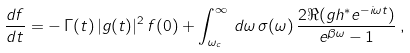Convert formula to latex. <formula><loc_0><loc_0><loc_500><loc_500>\frac { d f } { d t } = - \, \Gamma ( t ) \, | g ( t ) | ^ { 2 } \, f ( 0 ) + \int _ { \omega _ { c } } ^ { \infty } \, d \omega \, \sigma ( \omega ) \, \frac { 2 \Re ( g h ^ { * } e ^ { - i \omega t } ) } { e ^ { \beta \omega } - 1 } \, ,</formula> 